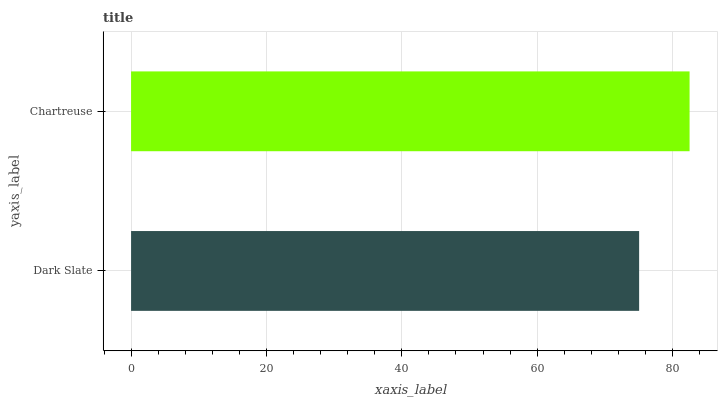Is Dark Slate the minimum?
Answer yes or no. Yes. Is Chartreuse the maximum?
Answer yes or no. Yes. Is Chartreuse the minimum?
Answer yes or no. No. Is Chartreuse greater than Dark Slate?
Answer yes or no. Yes. Is Dark Slate less than Chartreuse?
Answer yes or no. Yes. Is Dark Slate greater than Chartreuse?
Answer yes or no. No. Is Chartreuse less than Dark Slate?
Answer yes or no. No. Is Chartreuse the high median?
Answer yes or no. Yes. Is Dark Slate the low median?
Answer yes or no. Yes. Is Dark Slate the high median?
Answer yes or no. No. Is Chartreuse the low median?
Answer yes or no. No. 